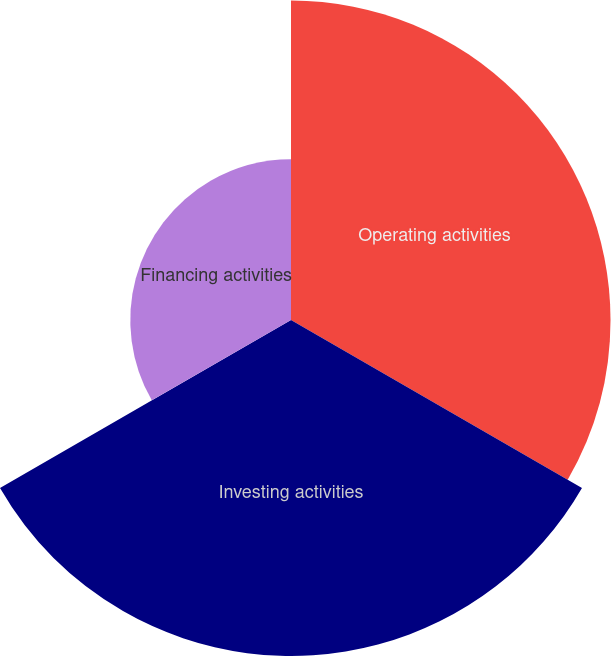<chart> <loc_0><loc_0><loc_500><loc_500><pie_chart><fcel>Operating activities<fcel>Investing activities<fcel>Financing activities<nl><fcel>39.14%<fcel>41.16%<fcel>19.69%<nl></chart> 